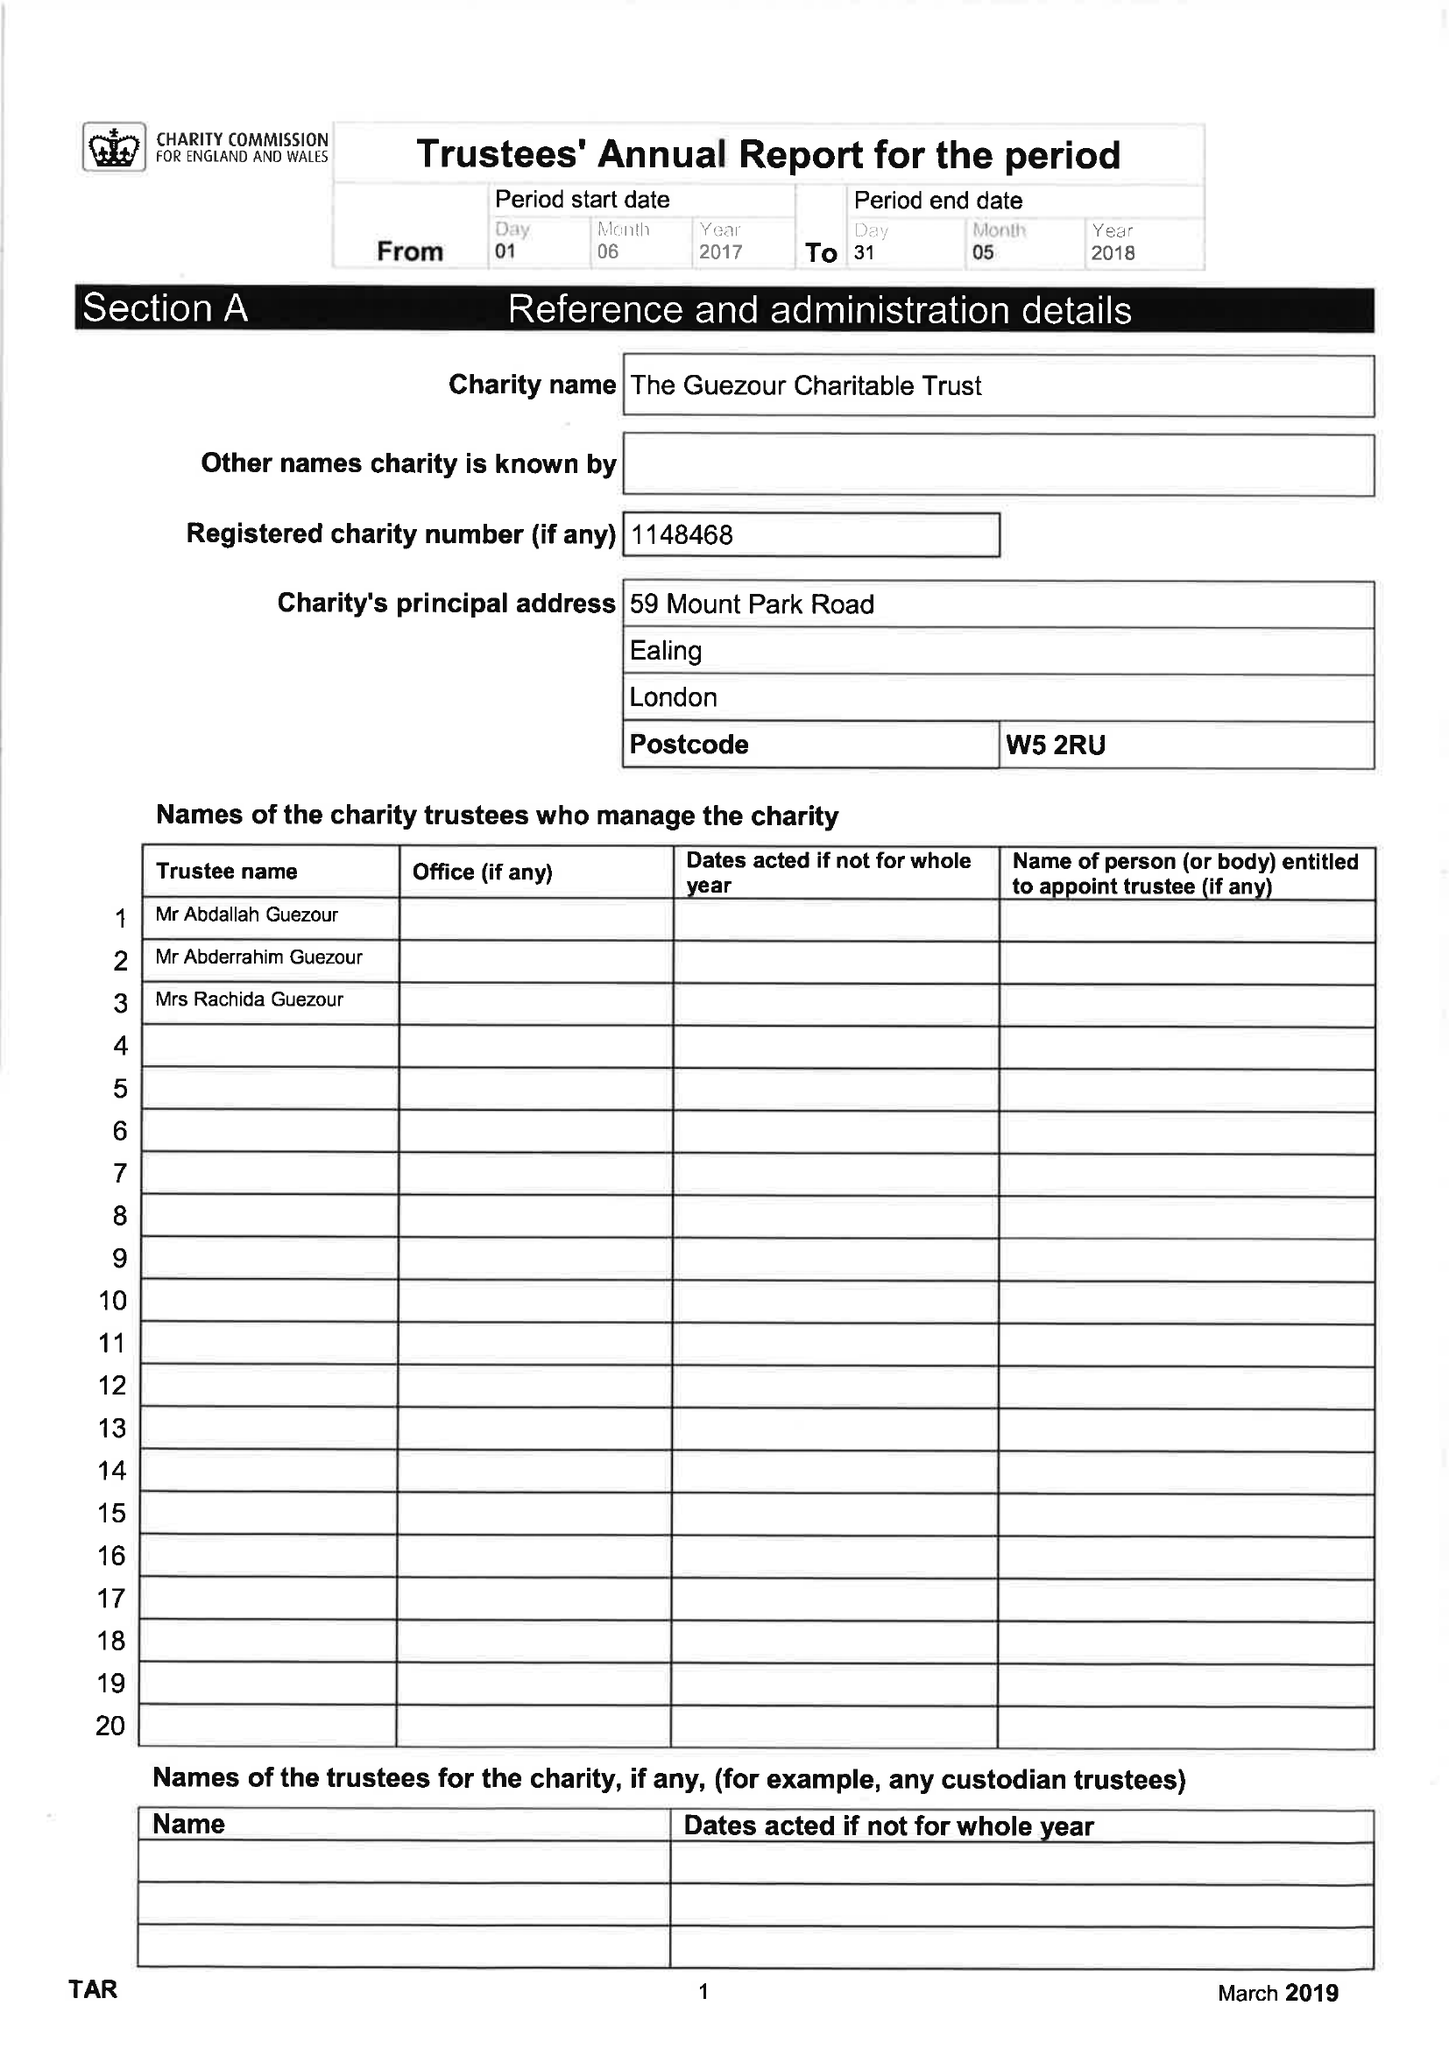What is the value for the report_date?
Answer the question using a single word or phrase. 2018-05-31 